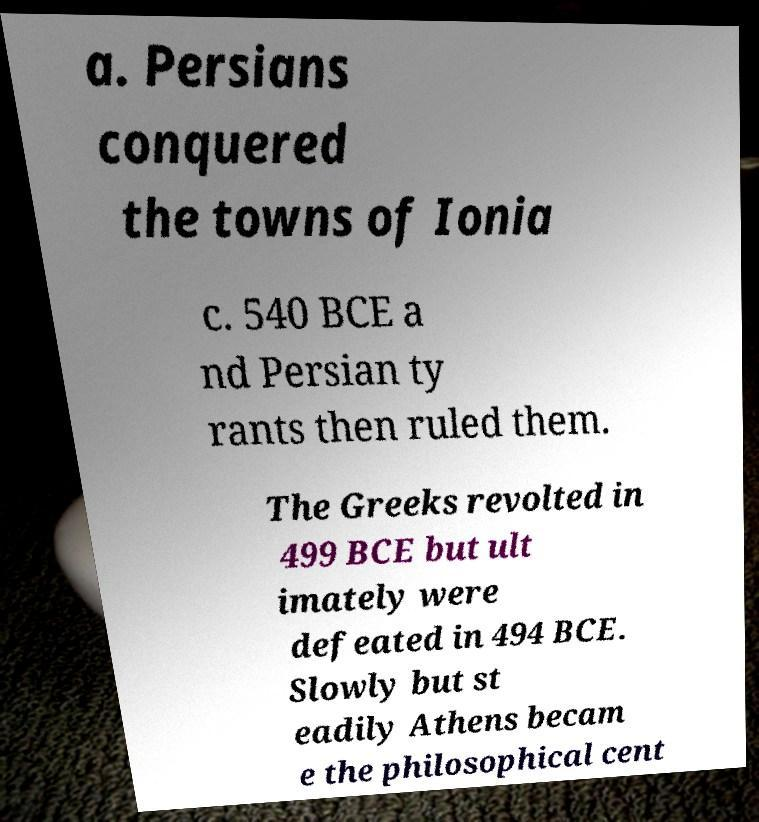I need the written content from this picture converted into text. Can you do that? a. Persians conquered the towns of Ionia c. 540 BCE a nd Persian ty rants then ruled them. The Greeks revolted in 499 BCE but ult imately were defeated in 494 BCE. Slowly but st eadily Athens becam e the philosophical cent 